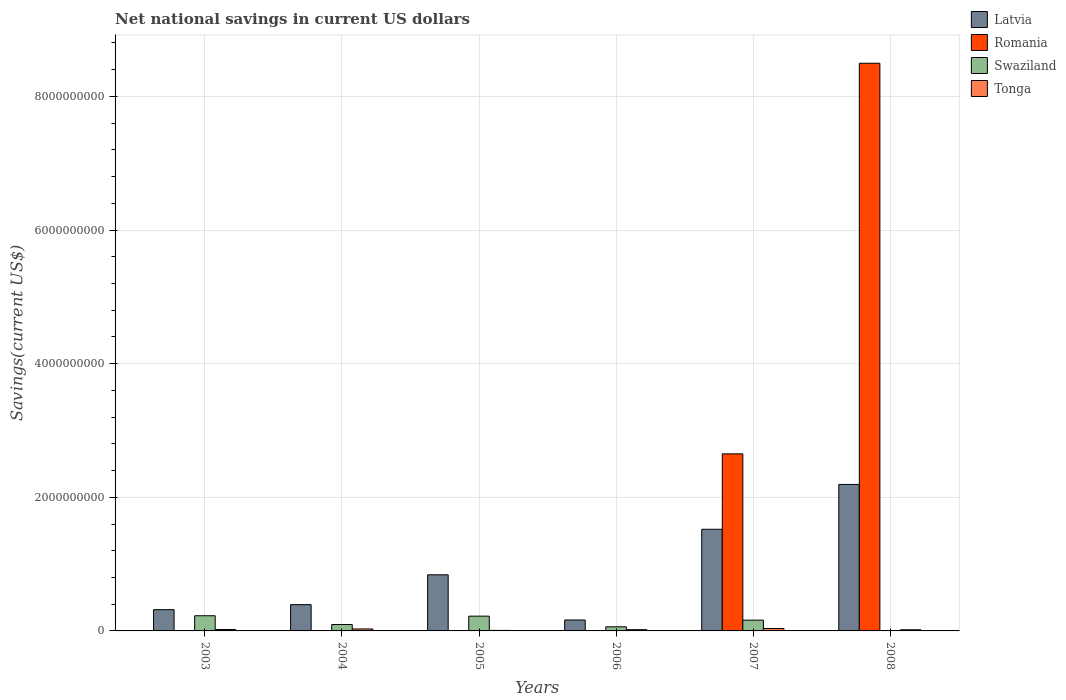How many bars are there on the 6th tick from the left?
Offer a terse response. 3. How many bars are there on the 1st tick from the right?
Make the answer very short. 3. What is the label of the 2nd group of bars from the left?
Provide a short and direct response. 2004. In how many cases, is the number of bars for a given year not equal to the number of legend labels?
Keep it short and to the point. 5. What is the net national savings in Romania in 2006?
Provide a short and direct response. 0. Across all years, what is the maximum net national savings in Tonga?
Ensure brevity in your answer.  3.64e+07. In which year was the net national savings in Tonga maximum?
Provide a succinct answer. 2007. What is the total net national savings in Tonga in the graph?
Offer a very short reply. 1.30e+08. What is the difference between the net national savings in Swaziland in 2004 and that in 2007?
Provide a short and direct response. -6.54e+07. What is the difference between the net national savings in Latvia in 2006 and the net national savings in Swaziland in 2004?
Make the answer very short. 6.78e+07. What is the average net national savings in Latvia per year?
Your response must be concise. 9.05e+08. In the year 2003, what is the difference between the net national savings in Tonga and net national savings in Latvia?
Provide a short and direct response. -2.97e+08. In how many years, is the net national savings in Swaziland greater than 7200000000 US$?
Ensure brevity in your answer.  0. What is the ratio of the net national savings in Latvia in 2003 to that in 2006?
Offer a very short reply. 1.94. Is the net national savings in Swaziland in 2004 less than that in 2006?
Your response must be concise. No. What is the difference between the highest and the second highest net national savings in Latvia?
Make the answer very short. 6.71e+08. What is the difference between the highest and the lowest net national savings in Latvia?
Your response must be concise. 2.03e+09. Is it the case that in every year, the sum of the net national savings in Swaziland and net national savings in Latvia is greater than the sum of net national savings in Tonga and net national savings in Romania?
Offer a terse response. No. Is it the case that in every year, the sum of the net national savings in Swaziland and net national savings in Latvia is greater than the net national savings in Tonga?
Your answer should be very brief. Yes. How many bars are there?
Ensure brevity in your answer.  19. What is the difference between two consecutive major ticks on the Y-axis?
Provide a short and direct response. 2.00e+09. Does the graph contain grids?
Ensure brevity in your answer.  Yes. Where does the legend appear in the graph?
Make the answer very short. Top right. What is the title of the graph?
Keep it short and to the point. Net national savings in current US dollars. Does "Liberia" appear as one of the legend labels in the graph?
Offer a terse response. No. What is the label or title of the X-axis?
Offer a terse response. Years. What is the label or title of the Y-axis?
Offer a terse response. Savings(current US$). What is the Savings(current US$) of Latvia in 2003?
Your answer should be very brief. 3.18e+08. What is the Savings(current US$) in Swaziland in 2003?
Your answer should be compact. 2.27e+08. What is the Savings(current US$) in Tonga in 2003?
Your answer should be compact. 2.06e+07. What is the Savings(current US$) of Latvia in 2004?
Give a very brief answer. 3.93e+08. What is the Savings(current US$) of Romania in 2004?
Give a very brief answer. 0. What is the Savings(current US$) in Swaziland in 2004?
Offer a terse response. 9.58e+07. What is the Savings(current US$) of Tonga in 2004?
Provide a succinct answer. 2.94e+07. What is the Savings(current US$) of Latvia in 2005?
Your answer should be compact. 8.40e+08. What is the Savings(current US$) of Romania in 2005?
Make the answer very short. 0. What is the Savings(current US$) in Swaziland in 2005?
Your response must be concise. 2.21e+08. What is the Savings(current US$) in Tonga in 2005?
Ensure brevity in your answer.  7.90e+06. What is the Savings(current US$) of Latvia in 2006?
Offer a terse response. 1.64e+08. What is the Savings(current US$) in Romania in 2006?
Offer a terse response. 0. What is the Savings(current US$) of Swaziland in 2006?
Provide a short and direct response. 6.16e+07. What is the Savings(current US$) of Tonga in 2006?
Make the answer very short. 1.85e+07. What is the Savings(current US$) in Latvia in 2007?
Make the answer very short. 1.52e+09. What is the Savings(current US$) in Romania in 2007?
Give a very brief answer. 2.65e+09. What is the Savings(current US$) in Swaziland in 2007?
Keep it short and to the point. 1.61e+08. What is the Savings(current US$) of Tonga in 2007?
Your answer should be compact. 3.64e+07. What is the Savings(current US$) in Latvia in 2008?
Provide a succinct answer. 2.19e+09. What is the Savings(current US$) in Romania in 2008?
Ensure brevity in your answer.  8.50e+09. What is the Savings(current US$) in Swaziland in 2008?
Keep it short and to the point. 0. What is the Savings(current US$) of Tonga in 2008?
Offer a very short reply. 1.72e+07. Across all years, what is the maximum Savings(current US$) of Latvia?
Your answer should be compact. 2.19e+09. Across all years, what is the maximum Savings(current US$) of Romania?
Ensure brevity in your answer.  8.50e+09. Across all years, what is the maximum Savings(current US$) in Swaziland?
Your response must be concise. 2.27e+08. Across all years, what is the maximum Savings(current US$) of Tonga?
Your response must be concise. 3.64e+07. Across all years, what is the minimum Savings(current US$) of Latvia?
Keep it short and to the point. 1.64e+08. Across all years, what is the minimum Savings(current US$) in Romania?
Ensure brevity in your answer.  0. Across all years, what is the minimum Savings(current US$) in Tonga?
Offer a very short reply. 7.90e+06. What is the total Savings(current US$) in Latvia in the graph?
Provide a short and direct response. 5.43e+09. What is the total Savings(current US$) in Romania in the graph?
Ensure brevity in your answer.  1.11e+1. What is the total Savings(current US$) in Swaziland in the graph?
Offer a terse response. 7.67e+08. What is the total Savings(current US$) in Tonga in the graph?
Make the answer very short. 1.30e+08. What is the difference between the Savings(current US$) of Latvia in 2003 and that in 2004?
Your answer should be compact. -7.53e+07. What is the difference between the Savings(current US$) in Swaziland in 2003 and that in 2004?
Your response must be concise. 1.31e+08. What is the difference between the Savings(current US$) of Tonga in 2003 and that in 2004?
Ensure brevity in your answer.  -8.76e+06. What is the difference between the Savings(current US$) of Latvia in 2003 and that in 2005?
Make the answer very short. -5.22e+08. What is the difference between the Savings(current US$) of Swaziland in 2003 and that in 2005?
Make the answer very short. 6.12e+06. What is the difference between the Savings(current US$) in Tonga in 2003 and that in 2005?
Give a very brief answer. 1.27e+07. What is the difference between the Savings(current US$) of Latvia in 2003 and that in 2006?
Provide a short and direct response. 1.54e+08. What is the difference between the Savings(current US$) of Swaziland in 2003 and that in 2006?
Your answer should be compact. 1.66e+08. What is the difference between the Savings(current US$) in Tonga in 2003 and that in 2006?
Provide a succinct answer. 2.07e+06. What is the difference between the Savings(current US$) in Latvia in 2003 and that in 2007?
Provide a short and direct response. -1.20e+09. What is the difference between the Savings(current US$) of Swaziland in 2003 and that in 2007?
Your response must be concise. 6.59e+07. What is the difference between the Savings(current US$) of Tonga in 2003 and that in 2007?
Your answer should be very brief. -1.58e+07. What is the difference between the Savings(current US$) in Latvia in 2003 and that in 2008?
Your answer should be very brief. -1.87e+09. What is the difference between the Savings(current US$) of Tonga in 2003 and that in 2008?
Keep it short and to the point. 3.43e+06. What is the difference between the Savings(current US$) in Latvia in 2004 and that in 2005?
Make the answer very short. -4.47e+08. What is the difference between the Savings(current US$) in Swaziland in 2004 and that in 2005?
Offer a very short reply. -1.25e+08. What is the difference between the Savings(current US$) of Tonga in 2004 and that in 2005?
Keep it short and to the point. 2.15e+07. What is the difference between the Savings(current US$) in Latvia in 2004 and that in 2006?
Provide a succinct answer. 2.30e+08. What is the difference between the Savings(current US$) in Swaziland in 2004 and that in 2006?
Make the answer very short. 3.42e+07. What is the difference between the Savings(current US$) in Tonga in 2004 and that in 2006?
Offer a very short reply. 1.08e+07. What is the difference between the Savings(current US$) of Latvia in 2004 and that in 2007?
Provide a short and direct response. -1.13e+09. What is the difference between the Savings(current US$) of Swaziland in 2004 and that in 2007?
Provide a short and direct response. -6.54e+07. What is the difference between the Savings(current US$) in Tonga in 2004 and that in 2007?
Offer a terse response. -7.02e+06. What is the difference between the Savings(current US$) of Latvia in 2004 and that in 2008?
Your answer should be very brief. -1.80e+09. What is the difference between the Savings(current US$) of Tonga in 2004 and that in 2008?
Your answer should be very brief. 1.22e+07. What is the difference between the Savings(current US$) in Latvia in 2005 and that in 2006?
Provide a succinct answer. 6.76e+08. What is the difference between the Savings(current US$) of Swaziland in 2005 and that in 2006?
Offer a very short reply. 1.59e+08. What is the difference between the Savings(current US$) in Tonga in 2005 and that in 2006?
Your response must be concise. -1.06e+07. What is the difference between the Savings(current US$) in Latvia in 2005 and that in 2007?
Make the answer very short. -6.81e+08. What is the difference between the Savings(current US$) of Swaziland in 2005 and that in 2007?
Ensure brevity in your answer.  5.98e+07. What is the difference between the Savings(current US$) in Tonga in 2005 and that in 2007?
Offer a terse response. -2.85e+07. What is the difference between the Savings(current US$) of Latvia in 2005 and that in 2008?
Offer a terse response. -1.35e+09. What is the difference between the Savings(current US$) of Tonga in 2005 and that in 2008?
Your answer should be very brief. -9.28e+06. What is the difference between the Savings(current US$) of Latvia in 2006 and that in 2007?
Give a very brief answer. -1.36e+09. What is the difference between the Savings(current US$) in Swaziland in 2006 and that in 2007?
Ensure brevity in your answer.  -9.97e+07. What is the difference between the Savings(current US$) in Tonga in 2006 and that in 2007?
Offer a very short reply. -1.78e+07. What is the difference between the Savings(current US$) in Latvia in 2006 and that in 2008?
Offer a very short reply. -2.03e+09. What is the difference between the Savings(current US$) in Tonga in 2006 and that in 2008?
Your response must be concise. 1.36e+06. What is the difference between the Savings(current US$) of Latvia in 2007 and that in 2008?
Provide a succinct answer. -6.71e+08. What is the difference between the Savings(current US$) in Romania in 2007 and that in 2008?
Give a very brief answer. -5.85e+09. What is the difference between the Savings(current US$) of Tonga in 2007 and that in 2008?
Ensure brevity in your answer.  1.92e+07. What is the difference between the Savings(current US$) in Latvia in 2003 and the Savings(current US$) in Swaziland in 2004?
Your answer should be compact. 2.22e+08. What is the difference between the Savings(current US$) of Latvia in 2003 and the Savings(current US$) of Tonga in 2004?
Offer a terse response. 2.89e+08. What is the difference between the Savings(current US$) of Swaziland in 2003 and the Savings(current US$) of Tonga in 2004?
Your answer should be very brief. 1.98e+08. What is the difference between the Savings(current US$) in Latvia in 2003 and the Savings(current US$) in Swaziland in 2005?
Provide a succinct answer. 9.71e+07. What is the difference between the Savings(current US$) of Latvia in 2003 and the Savings(current US$) of Tonga in 2005?
Make the answer very short. 3.10e+08. What is the difference between the Savings(current US$) in Swaziland in 2003 and the Savings(current US$) in Tonga in 2005?
Your response must be concise. 2.19e+08. What is the difference between the Savings(current US$) of Latvia in 2003 and the Savings(current US$) of Swaziland in 2006?
Ensure brevity in your answer.  2.57e+08. What is the difference between the Savings(current US$) in Latvia in 2003 and the Savings(current US$) in Tonga in 2006?
Provide a succinct answer. 3.00e+08. What is the difference between the Savings(current US$) of Swaziland in 2003 and the Savings(current US$) of Tonga in 2006?
Offer a very short reply. 2.09e+08. What is the difference between the Savings(current US$) in Latvia in 2003 and the Savings(current US$) in Romania in 2007?
Make the answer very short. -2.33e+09. What is the difference between the Savings(current US$) in Latvia in 2003 and the Savings(current US$) in Swaziland in 2007?
Provide a short and direct response. 1.57e+08. What is the difference between the Savings(current US$) of Latvia in 2003 and the Savings(current US$) of Tonga in 2007?
Ensure brevity in your answer.  2.82e+08. What is the difference between the Savings(current US$) of Swaziland in 2003 and the Savings(current US$) of Tonga in 2007?
Offer a terse response. 1.91e+08. What is the difference between the Savings(current US$) of Latvia in 2003 and the Savings(current US$) of Romania in 2008?
Provide a short and direct response. -8.18e+09. What is the difference between the Savings(current US$) in Latvia in 2003 and the Savings(current US$) in Tonga in 2008?
Offer a terse response. 3.01e+08. What is the difference between the Savings(current US$) in Swaziland in 2003 and the Savings(current US$) in Tonga in 2008?
Your answer should be compact. 2.10e+08. What is the difference between the Savings(current US$) of Latvia in 2004 and the Savings(current US$) of Swaziland in 2005?
Your answer should be very brief. 1.72e+08. What is the difference between the Savings(current US$) in Latvia in 2004 and the Savings(current US$) in Tonga in 2005?
Make the answer very short. 3.86e+08. What is the difference between the Savings(current US$) in Swaziland in 2004 and the Savings(current US$) in Tonga in 2005?
Your answer should be very brief. 8.79e+07. What is the difference between the Savings(current US$) of Latvia in 2004 and the Savings(current US$) of Swaziland in 2006?
Your response must be concise. 3.32e+08. What is the difference between the Savings(current US$) in Latvia in 2004 and the Savings(current US$) in Tonga in 2006?
Provide a short and direct response. 3.75e+08. What is the difference between the Savings(current US$) in Swaziland in 2004 and the Savings(current US$) in Tonga in 2006?
Offer a terse response. 7.73e+07. What is the difference between the Savings(current US$) in Latvia in 2004 and the Savings(current US$) in Romania in 2007?
Provide a succinct answer. -2.26e+09. What is the difference between the Savings(current US$) of Latvia in 2004 and the Savings(current US$) of Swaziland in 2007?
Give a very brief answer. 2.32e+08. What is the difference between the Savings(current US$) of Latvia in 2004 and the Savings(current US$) of Tonga in 2007?
Provide a succinct answer. 3.57e+08. What is the difference between the Savings(current US$) in Swaziland in 2004 and the Savings(current US$) in Tonga in 2007?
Offer a terse response. 5.94e+07. What is the difference between the Savings(current US$) of Latvia in 2004 and the Savings(current US$) of Romania in 2008?
Your response must be concise. -8.10e+09. What is the difference between the Savings(current US$) in Latvia in 2004 and the Savings(current US$) in Tonga in 2008?
Provide a succinct answer. 3.76e+08. What is the difference between the Savings(current US$) in Swaziland in 2004 and the Savings(current US$) in Tonga in 2008?
Keep it short and to the point. 7.86e+07. What is the difference between the Savings(current US$) of Latvia in 2005 and the Savings(current US$) of Swaziland in 2006?
Make the answer very short. 7.78e+08. What is the difference between the Savings(current US$) of Latvia in 2005 and the Savings(current US$) of Tonga in 2006?
Your response must be concise. 8.21e+08. What is the difference between the Savings(current US$) of Swaziland in 2005 and the Savings(current US$) of Tonga in 2006?
Provide a short and direct response. 2.03e+08. What is the difference between the Savings(current US$) in Latvia in 2005 and the Savings(current US$) in Romania in 2007?
Ensure brevity in your answer.  -1.81e+09. What is the difference between the Savings(current US$) of Latvia in 2005 and the Savings(current US$) of Swaziland in 2007?
Provide a short and direct response. 6.79e+08. What is the difference between the Savings(current US$) in Latvia in 2005 and the Savings(current US$) in Tonga in 2007?
Offer a terse response. 8.04e+08. What is the difference between the Savings(current US$) in Swaziland in 2005 and the Savings(current US$) in Tonga in 2007?
Your response must be concise. 1.85e+08. What is the difference between the Savings(current US$) of Latvia in 2005 and the Savings(current US$) of Romania in 2008?
Offer a very short reply. -7.66e+09. What is the difference between the Savings(current US$) in Latvia in 2005 and the Savings(current US$) in Tonga in 2008?
Offer a very short reply. 8.23e+08. What is the difference between the Savings(current US$) of Swaziland in 2005 and the Savings(current US$) of Tonga in 2008?
Provide a short and direct response. 2.04e+08. What is the difference between the Savings(current US$) of Latvia in 2006 and the Savings(current US$) of Romania in 2007?
Your answer should be very brief. -2.49e+09. What is the difference between the Savings(current US$) of Latvia in 2006 and the Savings(current US$) of Swaziland in 2007?
Provide a short and direct response. 2.36e+06. What is the difference between the Savings(current US$) of Latvia in 2006 and the Savings(current US$) of Tonga in 2007?
Provide a short and direct response. 1.27e+08. What is the difference between the Savings(current US$) in Swaziland in 2006 and the Savings(current US$) in Tonga in 2007?
Provide a succinct answer. 2.52e+07. What is the difference between the Savings(current US$) in Latvia in 2006 and the Savings(current US$) in Romania in 2008?
Ensure brevity in your answer.  -8.33e+09. What is the difference between the Savings(current US$) in Latvia in 2006 and the Savings(current US$) in Tonga in 2008?
Offer a terse response. 1.46e+08. What is the difference between the Savings(current US$) of Swaziland in 2006 and the Savings(current US$) of Tonga in 2008?
Provide a succinct answer. 4.44e+07. What is the difference between the Savings(current US$) in Latvia in 2007 and the Savings(current US$) in Romania in 2008?
Ensure brevity in your answer.  -6.97e+09. What is the difference between the Savings(current US$) in Latvia in 2007 and the Savings(current US$) in Tonga in 2008?
Keep it short and to the point. 1.50e+09. What is the difference between the Savings(current US$) of Romania in 2007 and the Savings(current US$) of Tonga in 2008?
Keep it short and to the point. 2.63e+09. What is the difference between the Savings(current US$) of Swaziland in 2007 and the Savings(current US$) of Tonga in 2008?
Provide a short and direct response. 1.44e+08. What is the average Savings(current US$) in Latvia per year?
Make the answer very short. 9.05e+08. What is the average Savings(current US$) of Romania per year?
Provide a succinct answer. 1.86e+09. What is the average Savings(current US$) in Swaziland per year?
Offer a very short reply. 1.28e+08. What is the average Savings(current US$) of Tonga per year?
Your response must be concise. 2.17e+07. In the year 2003, what is the difference between the Savings(current US$) in Latvia and Savings(current US$) in Swaziland?
Provide a short and direct response. 9.09e+07. In the year 2003, what is the difference between the Savings(current US$) in Latvia and Savings(current US$) in Tonga?
Your answer should be very brief. 2.97e+08. In the year 2003, what is the difference between the Savings(current US$) of Swaziland and Savings(current US$) of Tonga?
Provide a short and direct response. 2.07e+08. In the year 2004, what is the difference between the Savings(current US$) of Latvia and Savings(current US$) of Swaziland?
Provide a short and direct response. 2.98e+08. In the year 2004, what is the difference between the Savings(current US$) in Latvia and Savings(current US$) in Tonga?
Your answer should be compact. 3.64e+08. In the year 2004, what is the difference between the Savings(current US$) in Swaziland and Savings(current US$) in Tonga?
Your response must be concise. 6.64e+07. In the year 2005, what is the difference between the Savings(current US$) of Latvia and Savings(current US$) of Swaziland?
Your answer should be compact. 6.19e+08. In the year 2005, what is the difference between the Savings(current US$) in Latvia and Savings(current US$) in Tonga?
Provide a short and direct response. 8.32e+08. In the year 2005, what is the difference between the Savings(current US$) of Swaziland and Savings(current US$) of Tonga?
Your response must be concise. 2.13e+08. In the year 2006, what is the difference between the Savings(current US$) in Latvia and Savings(current US$) in Swaziland?
Make the answer very short. 1.02e+08. In the year 2006, what is the difference between the Savings(current US$) of Latvia and Savings(current US$) of Tonga?
Offer a terse response. 1.45e+08. In the year 2006, what is the difference between the Savings(current US$) of Swaziland and Savings(current US$) of Tonga?
Offer a terse response. 4.30e+07. In the year 2007, what is the difference between the Savings(current US$) of Latvia and Savings(current US$) of Romania?
Your answer should be compact. -1.13e+09. In the year 2007, what is the difference between the Savings(current US$) of Latvia and Savings(current US$) of Swaziland?
Make the answer very short. 1.36e+09. In the year 2007, what is the difference between the Savings(current US$) of Latvia and Savings(current US$) of Tonga?
Offer a terse response. 1.48e+09. In the year 2007, what is the difference between the Savings(current US$) in Romania and Savings(current US$) in Swaziland?
Your response must be concise. 2.49e+09. In the year 2007, what is the difference between the Savings(current US$) in Romania and Savings(current US$) in Tonga?
Your answer should be very brief. 2.61e+09. In the year 2007, what is the difference between the Savings(current US$) in Swaziland and Savings(current US$) in Tonga?
Your answer should be compact. 1.25e+08. In the year 2008, what is the difference between the Savings(current US$) of Latvia and Savings(current US$) of Romania?
Offer a terse response. -6.30e+09. In the year 2008, what is the difference between the Savings(current US$) of Latvia and Savings(current US$) of Tonga?
Keep it short and to the point. 2.18e+09. In the year 2008, what is the difference between the Savings(current US$) in Romania and Savings(current US$) in Tonga?
Offer a terse response. 8.48e+09. What is the ratio of the Savings(current US$) in Latvia in 2003 to that in 2004?
Ensure brevity in your answer.  0.81. What is the ratio of the Savings(current US$) in Swaziland in 2003 to that in 2004?
Make the answer very short. 2.37. What is the ratio of the Savings(current US$) in Tonga in 2003 to that in 2004?
Your response must be concise. 0.7. What is the ratio of the Savings(current US$) of Latvia in 2003 to that in 2005?
Give a very brief answer. 0.38. What is the ratio of the Savings(current US$) in Swaziland in 2003 to that in 2005?
Provide a short and direct response. 1.03. What is the ratio of the Savings(current US$) of Tonga in 2003 to that in 2005?
Ensure brevity in your answer.  2.61. What is the ratio of the Savings(current US$) in Latvia in 2003 to that in 2006?
Offer a terse response. 1.94. What is the ratio of the Savings(current US$) of Swaziland in 2003 to that in 2006?
Your response must be concise. 3.69. What is the ratio of the Savings(current US$) in Tonga in 2003 to that in 2006?
Give a very brief answer. 1.11. What is the ratio of the Savings(current US$) in Latvia in 2003 to that in 2007?
Keep it short and to the point. 0.21. What is the ratio of the Savings(current US$) in Swaziland in 2003 to that in 2007?
Offer a terse response. 1.41. What is the ratio of the Savings(current US$) of Tonga in 2003 to that in 2007?
Ensure brevity in your answer.  0.57. What is the ratio of the Savings(current US$) of Latvia in 2003 to that in 2008?
Your answer should be compact. 0.15. What is the ratio of the Savings(current US$) in Tonga in 2003 to that in 2008?
Make the answer very short. 1.2. What is the ratio of the Savings(current US$) in Latvia in 2004 to that in 2005?
Your answer should be very brief. 0.47. What is the ratio of the Savings(current US$) in Swaziland in 2004 to that in 2005?
Give a very brief answer. 0.43. What is the ratio of the Savings(current US$) in Tonga in 2004 to that in 2005?
Provide a succinct answer. 3.72. What is the ratio of the Savings(current US$) of Latvia in 2004 to that in 2006?
Ensure brevity in your answer.  2.4. What is the ratio of the Savings(current US$) of Swaziland in 2004 to that in 2006?
Make the answer very short. 1.56. What is the ratio of the Savings(current US$) of Tonga in 2004 to that in 2006?
Provide a succinct answer. 1.58. What is the ratio of the Savings(current US$) of Latvia in 2004 to that in 2007?
Provide a short and direct response. 0.26. What is the ratio of the Savings(current US$) in Swaziland in 2004 to that in 2007?
Your answer should be very brief. 0.59. What is the ratio of the Savings(current US$) of Tonga in 2004 to that in 2007?
Make the answer very short. 0.81. What is the ratio of the Savings(current US$) of Latvia in 2004 to that in 2008?
Provide a succinct answer. 0.18. What is the ratio of the Savings(current US$) in Tonga in 2004 to that in 2008?
Your response must be concise. 1.71. What is the ratio of the Savings(current US$) of Latvia in 2005 to that in 2006?
Provide a succinct answer. 5.13. What is the ratio of the Savings(current US$) of Swaziland in 2005 to that in 2006?
Make the answer very short. 3.59. What is the ratio of the Savings(current US$) of Tonga in 2005 to that in 2006?
Provide a short and direct response. 0.43. What is the ratio of the Savings(current US$) in Latvia in 2005 to that in 2007?
Your answer should be compact. 0.55. What is the ratio of the Savings(current US$) in Swaziland in 2005 to that in 2007?
Make the answer very short. 1.37. What is the ratio of the Savings(current US$) in Tonga in 2005 to that in 2007?
Your answer should be very brief. 0.22. What is the ratio of the Savings(current US$) of Latvia in 2005 to that in 2008?
Provide a succinct answer. 0.38. What is the ratio of the Savings(current US$) of Tonga in 2005 to that in 2008?
Your answer should be compact. 0.46. What is the ratio of the Savings(current US$) of Latvia in 2006 to that in 2007?
Ensure brevity in your answer.  0.11. What is the ratio of the Savings(current US$) of Swaziland in 2006 to that in 2007?
Your response must be concise. 0.38. What is the ratio of the Savings(current US$) in Tonga in 2006 to that in 2007?
Keep it short and to the point. 0.51. What is the ratio of the Savings(current US$) in Latvia in 2006 to that in 2008?
Ensure brevity in your answer.  0.07. What is the ratio of the Savings(current US$) in Tonga in 2006 to that in 2008?
Offer a terse response. 1.08. What is the ratio of the Savings(current US$) in Latvia in 2007 to that in 2008?
Provide a succinct answer. 0.69. What is the ratio of the Savings(current US$) in Romania in 2007 to that in 2008?
Make the answer very short. 0.31. What is the ratio of the Savings(current US$) in Tonga in 2007 to that in 2008?
Keep it short and to the point. 2.12. What is the difference between the highest and the second highest Savings(current US$) of Latvia?
Give a very brief answer. 6.71e+08. What is the difference between the highest and the second highest Savings(current US$) in Swaziland?
Your response must be concise. 6.12e+06. What is the difference between the highest and the second highest Savings(current US$) of Tonga?
Offer a very short reply. 7.02e+06. What is the difference between the highest and the lowest Savings(current US$) in Latvia?
Ensure brevity in your answer.  2.03e+09. What is the difference between the highest and the lowest Savings(current US$) of Romania?
Offer a very short reply. 8.50e+09. What is the difference between the highest and the lowest Savings(current US$) in Swaziland?
Ensure brevity in your answer.  2.27e+08. What is the difference between the highest and the lowest Savings(current US$) of Tonga?
Offer a terse response. 2.85e+07. 